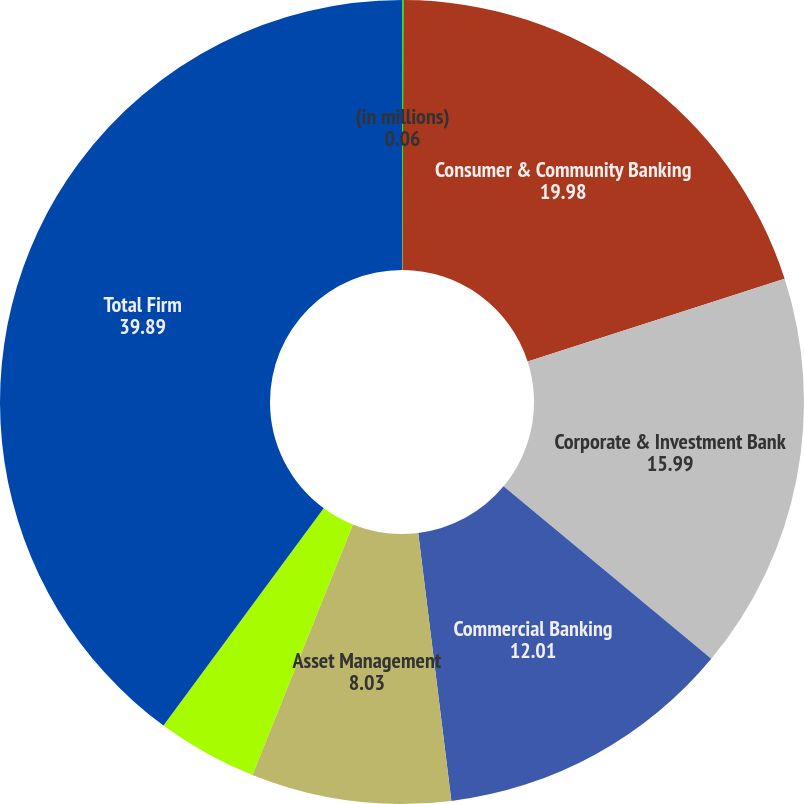Convert chart to OTSL. <chart><loc_0><loc_0><loc_500><loc_500><pie_chart><fcel>(in millions)<fcel>Consumer & Community Banking<fcel>Corporate & Investment Bank<fcel>Commercial Banking<fcel>Asset Management<fcel>Corporate<fcel>Total Firm<nl><fcel>0.06%<fcel>19.98%<fcel>15.99%<fcel>12.01%<fcel>8.03%<fcel>4.04%<fcel>39.89%<nl></chart> 